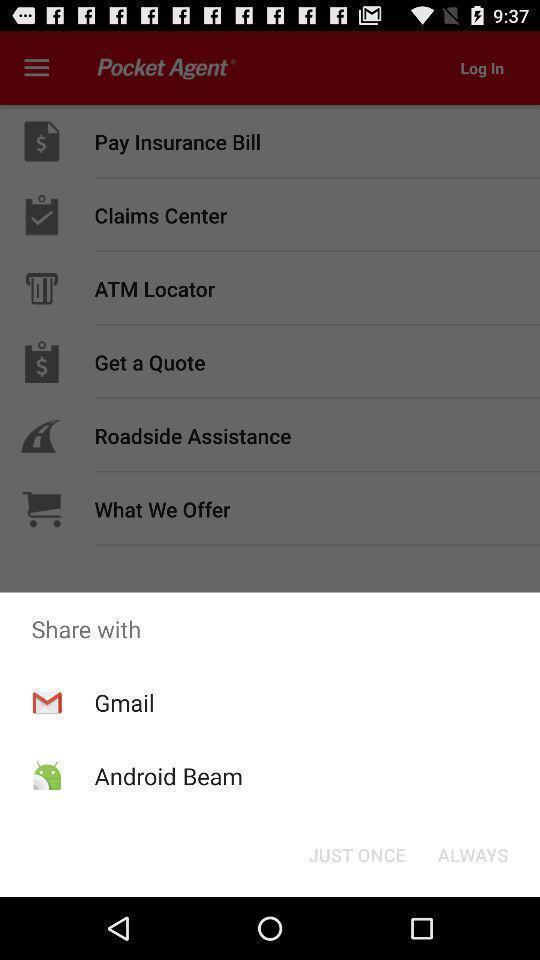Give me a narrative description of this picture. Popup of applications to share the information. 